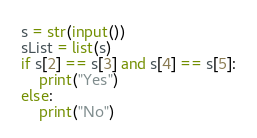Convert code to text. <code><loc_0><loc_0><loc_500><loc_500><_Python_>s = str(input())
sList = list(s)
if s[2] == s[3] and s[4] == s[5]:
	print("Yes")
else:
	print("No")</code> 